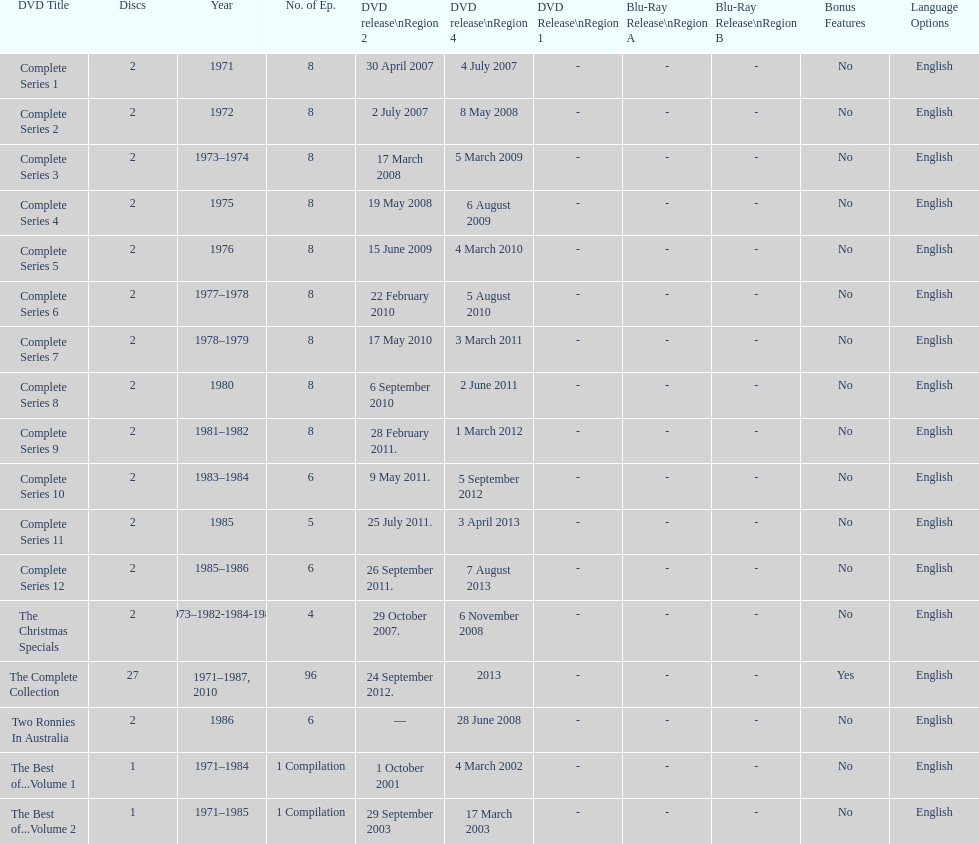True or false. the television show "the two ronnies" featured more than 10 episodes in a season. False. 